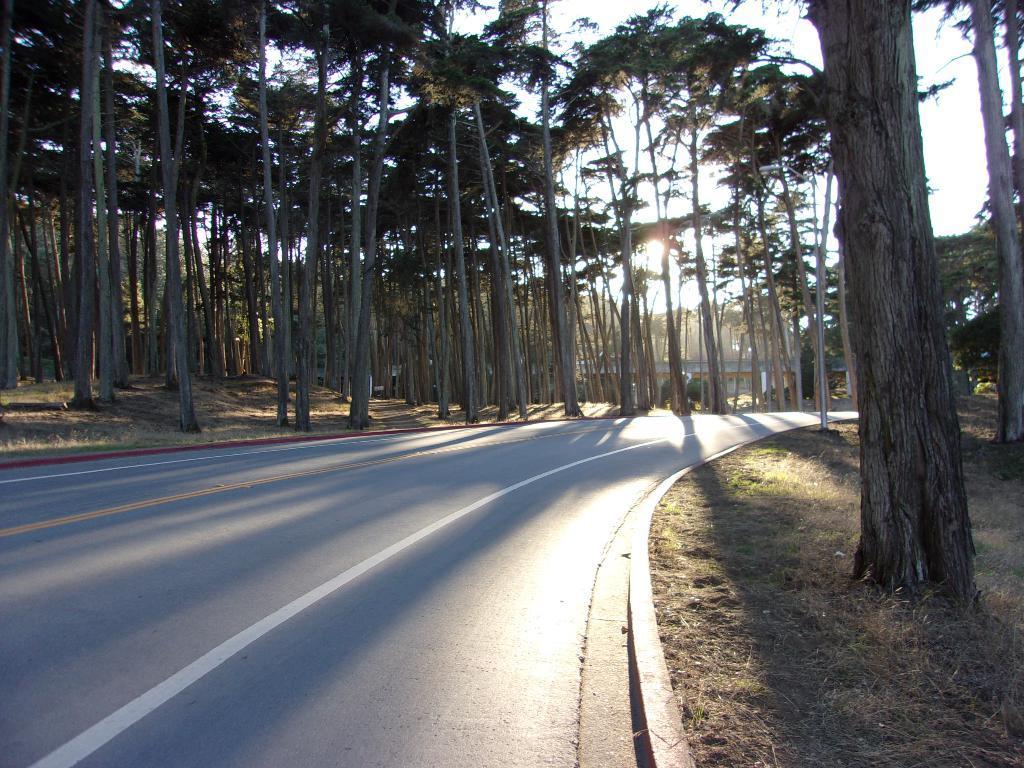Could you give a brief overview of what you see in this image? In this image I can see a road, background I can see trees in green color and the sky is in white color 